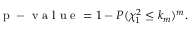<formula> <loc_0><loc_0><loc_500><loc_500>\begin{array} { r } { p - v a l u e = 1 - P ( \chi _ { 1 } ^ { 2 } \leq k _ { m } ) ^ { m } . } \end{array}</formula> 